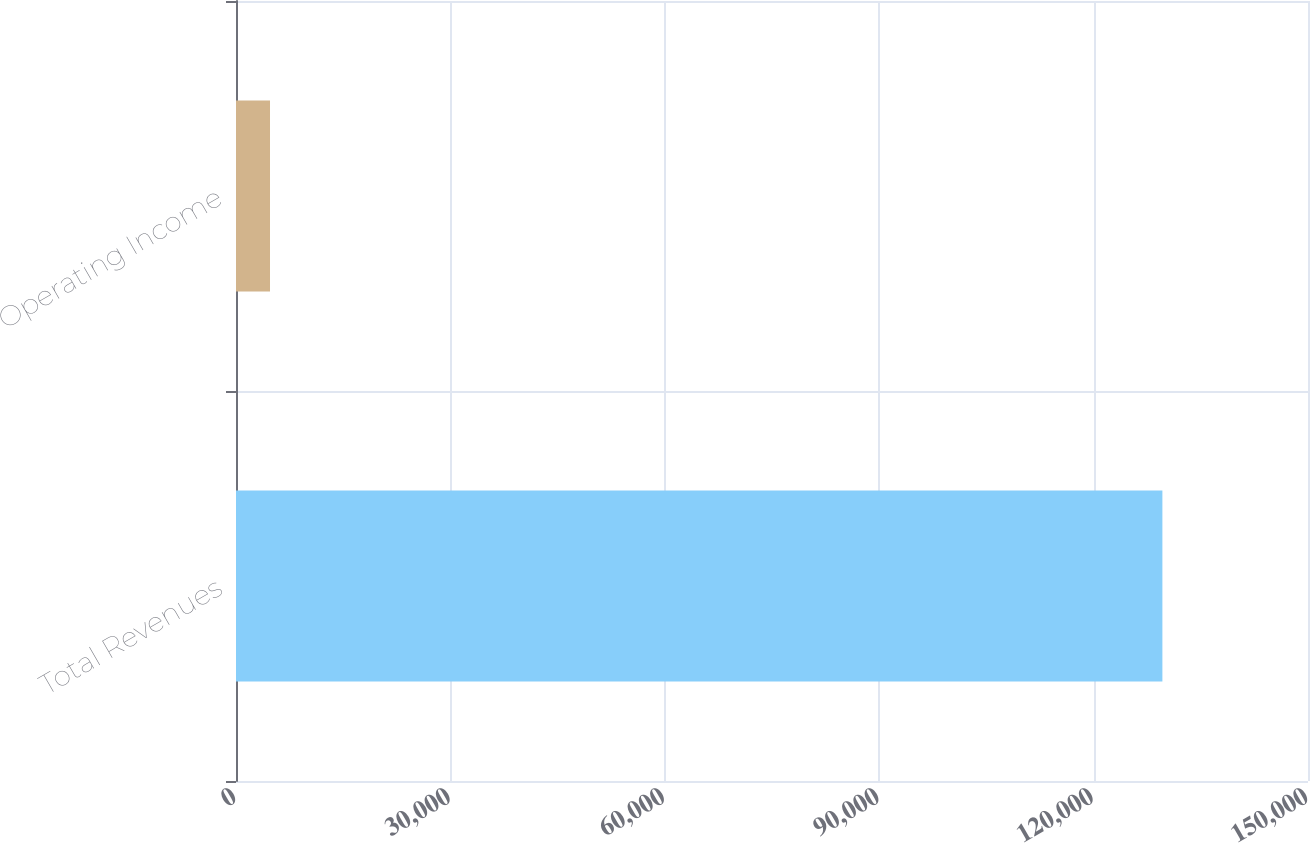<chart> <loc_0><loc_0><loc_500><loc_500><bar_chart><fcel>Total Revenues<fcel>Operating Income<nl><fcel>129626<fcel>4759<nl></chart> 